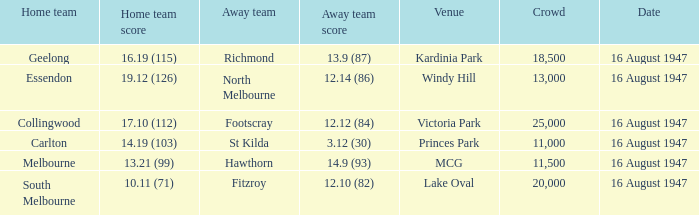Parse the table in full. {'header': ['Home team', 'Home team score', 'Away team', 'Away team score', 'Venue', 'Crowd', 'Date'], 'rows': [['Geelong', '16.19 (115)', 'Richmond', '13.9 (87)', 'Kardinia Park', '18,500', '16 August 1947'], ['Essendon', '19.12 (126)', 'North Melbourne', '12.14 (86)', 'Windy Hill', '13,000', '16 August 1947'], ['Collingwood', '17.10 (112)', 'Footscray', '12.12 (84)', 'Victoria Park', '25,000', '16 August 1947'], ['Carlton', '14.19 (103)', 'St Kilda', '3.12 (30)', 'Princes Park', '11,000', '16 August 1947'], ['Melbourne', '13.21 (99)', 'Hawthorn', '14.9 (93)', 'MCG', '11,500', '16 August 1947'], ['South Melbourne', '10.11 (71)', 'Fitzroy', '12.10 (82)', 'Lake Oval', '20,000', '16 August 1947']]} 10 (82)? 20000.0. 